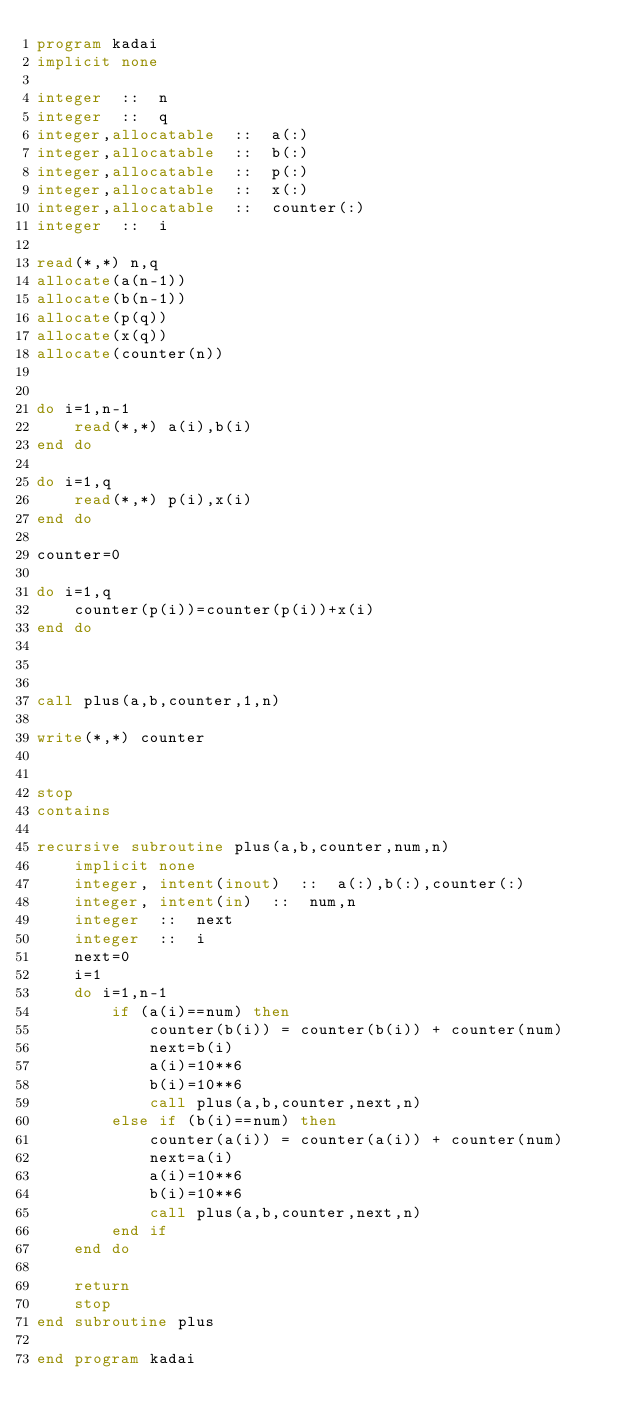Convert code to text. <code><loc_0><loc_0><loc_500><loc_500><_FORTRAN_>program kadai
implicit none

integer  ::  n
integer  ::  q
integer,allocatable  ::  a(:)
integer,allocatable  ::  b(:)
integer,allocatable  ::  p(:)
integer,allocatable  ::  x(:)
integer,allocatable  ::  counter(:)
integer  ::  i

read(*,*) n,q
allocate(a(n-1))
allocate(b(n-1))
allocate(p(q))
allocate(x(q))
allocate(counter(n))


do i=1,n-1
    read(*,*) a(i),b(i)
end do

do i=1,q
    read(*,*) p(i),x(i)
end do

counter=0

do i=1,q
    counter(p(i))=counter(p(i))+x(i)
end do



call plus(a,b,counter,1,n)

write(*,*) counter


stop
contains

recursive subroutine plus(a,b,counter,num,n)
    implicit none
    integer, intent(inout)  ::  a(:),b(:),counter(:)
    integer, intent(in)  ::  num,n
    integer  ::  next
    integer  ::  i
    next=0
    i=1
    do i=1,n-1
        if (a(i)==num) then
            counter(b(i)) = counter(b(i)) + counter(num)
            next=b(i)
            a(i)=10**6
            b(i)=10**6
            call plus(a,b,counter,next,n)
        else if (b(i)==num) then
            counter(a(i)) = counter(a(i)) + counter(num)
            next=a(i)
            a(i)=10**6
            b(i)=10**6
            call plus(a,b,counter,next,n)
        end if
    end do

    return
    stop
end subroutine plus

end program kadai
</code> 